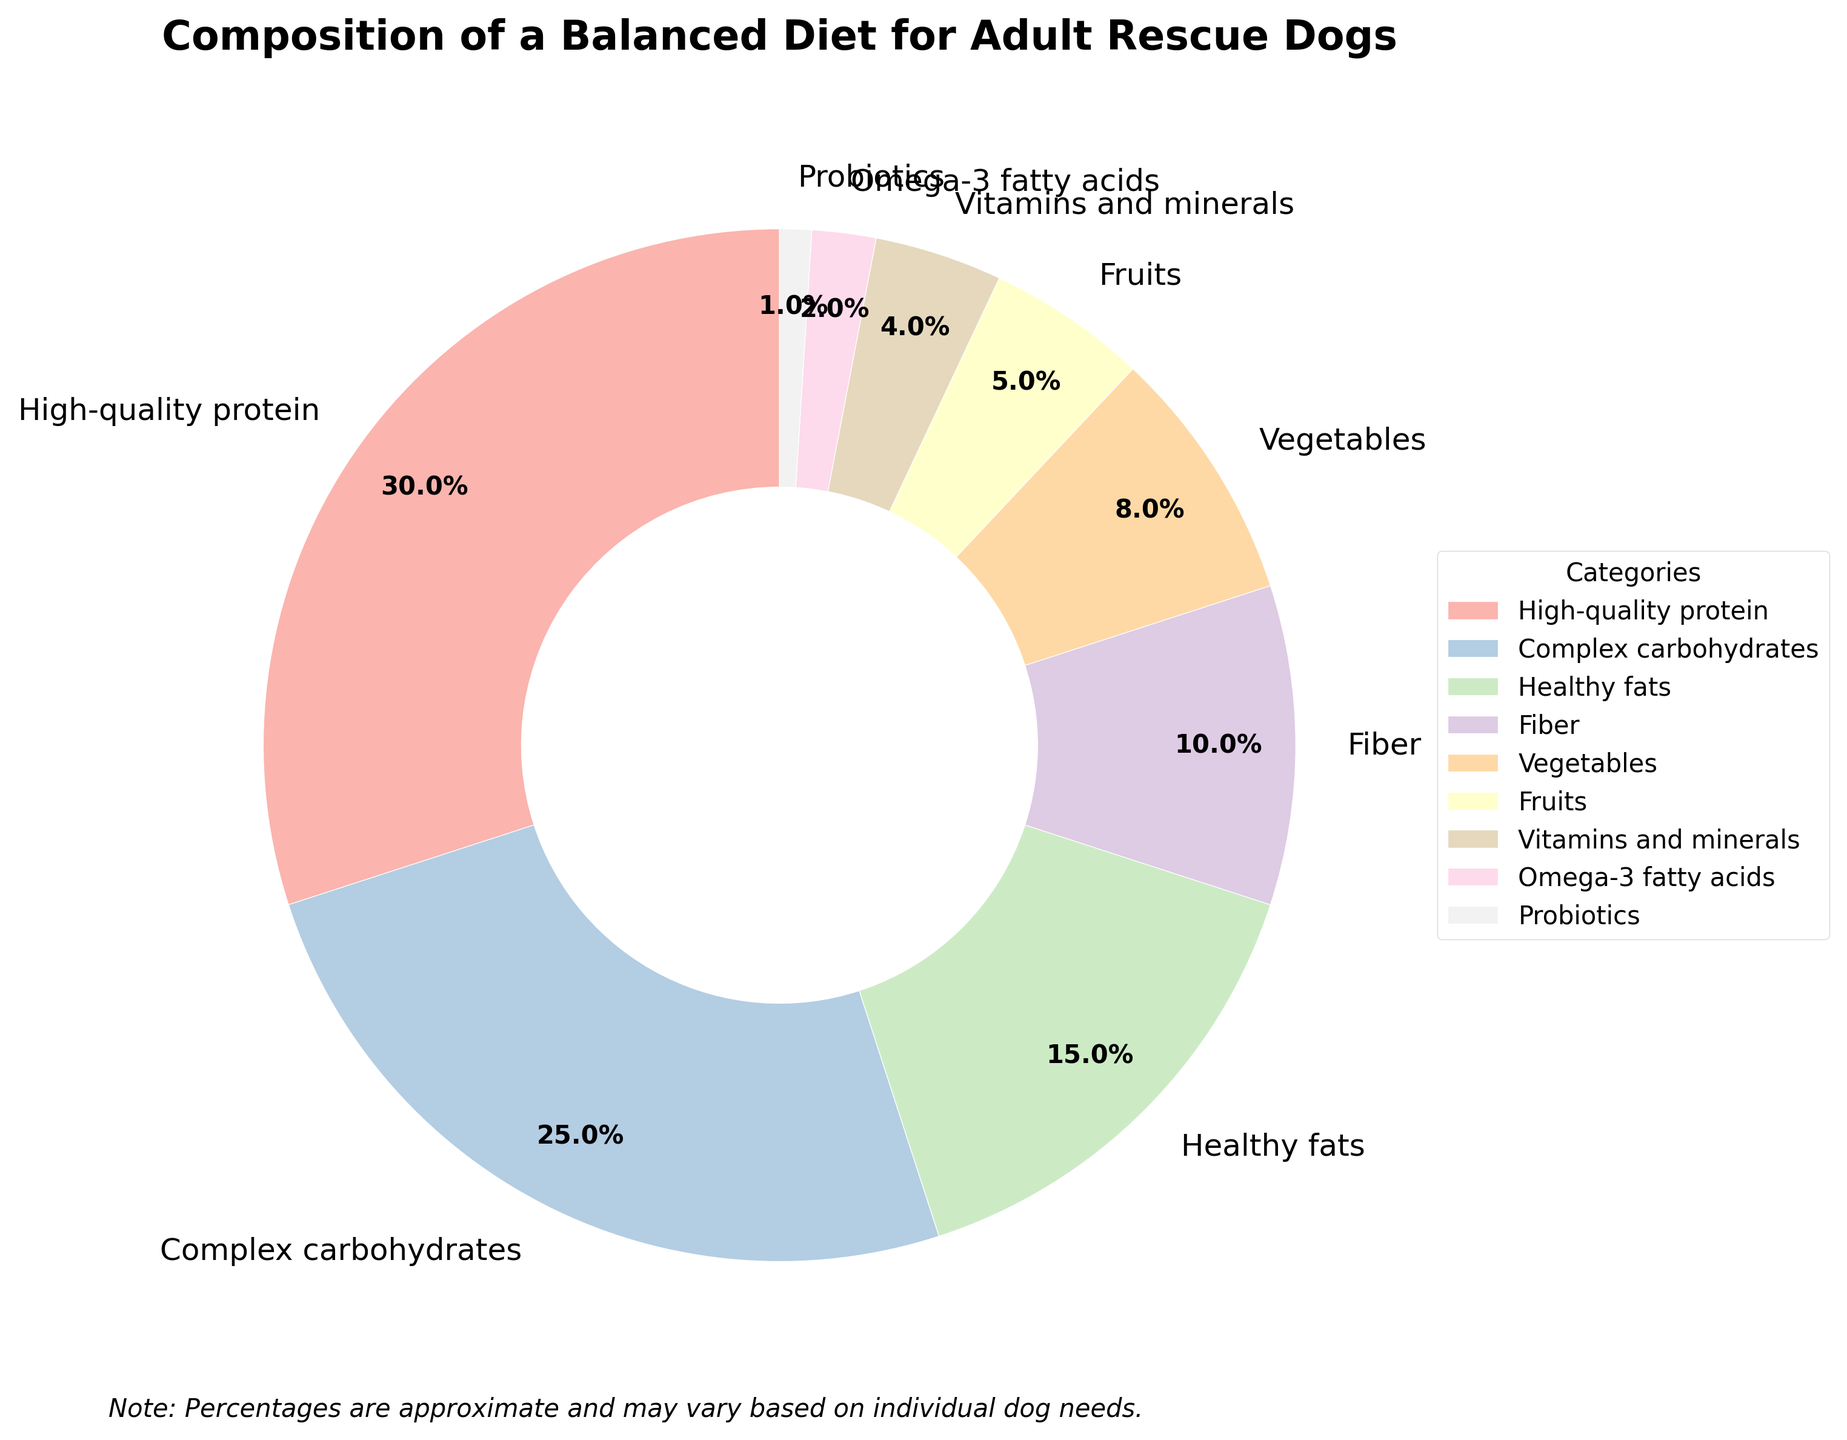What's the total percentage of high-quality protein, complex carbohydrates, and healthy fats? To find the total percentage, add the percentages of high-quality protein (30%), complex carbohydrates (25%), and healthy fats (15%): 30 + 25 + 15 = 70%
Answer: 70% Which category has the smallest percentage in the diet? By looking at the percentages, probiotics have the smallest share with 1%.
Answer: Probiotics How much higher is the percentage of complex carbohydrates compared to fruits? Subtract the percentage of fruits (5%) from complex carbohydrates (25%): 25 - 5 = 20%.
Answer: 20% Which category has a higher percentage, fiber or vegetables? Fiber accounts for 10% while vegetables account for 8%, hence fiber has a higher percentage.
Answer: Fiber What two categories combined make up one-fourth of the diet? Combine the percentages of complex carbohydrates (25%) and compare it to one-fourth (25%). Hence, complex carbohydrates alone make up one-fourth of the diet.
Answer: Complex carbohydrates What is the sum of the percentages for categories contributing less than 10% each? Add the percentages of vegetables (8%), fruits (5%), vitamins and minerals (4%), omega-3 fatty acids (2%), and probiotics (1%): 8 + 5 + 4 + 2 + 1 = 20%.
Answer: 20% What percentage of the diet is composed of fiber and omega-3 fatty acids together? Add the percentages of fiber (10%) and omega-3 fatty acids (2%): 10 + 2 = 12%.
Answer: 12% Which three categories together almost make up half of the diet? Add high-quality protein (30%), complex carbohydrates (25%), and healthy fats (15%), and compare to half (50%): 30 + 25 + 15 = 70%, which is more than half.
Answer: High-quality protein, complex carbohydrates, and healthy fats Is the percentage of healthy fats more than double that of vegetables? Double the percentage of vegetables (8%) is 16%, which is more than healthy fats (15%); hence the percentage of healthy fats is not more than double that of vegetables.
Answer: No How much higher is the percentage of high-quality protein than the combined percentage of vitamins and minerals and omega-3 fatty acids? Add the percentages of vitamins and minerals (4%) and omega-3 fatty acids (2%): 4 + 2 = 6%. Subtract this from high-quality protein (30%): 30 - 6 = 24%.
Answer: 24% 